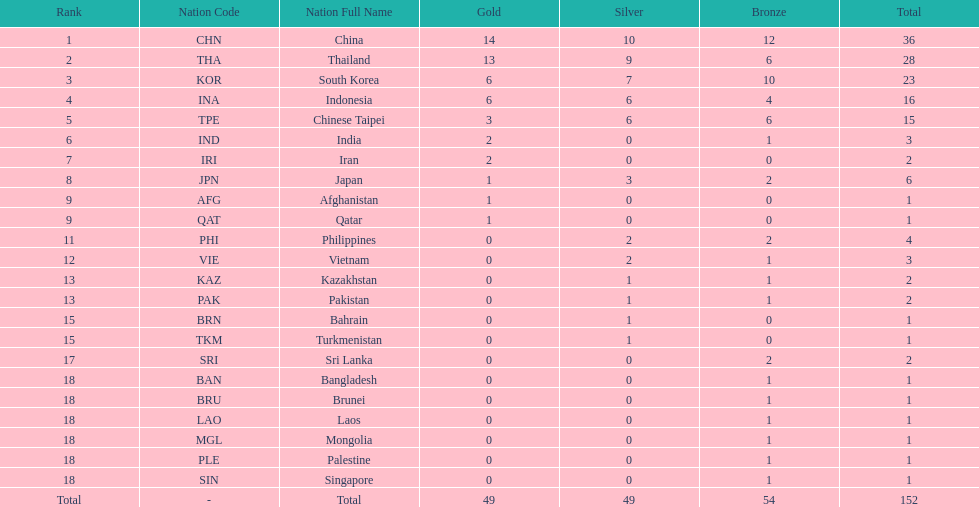How many nations received more than 5 gold medals? 4. 